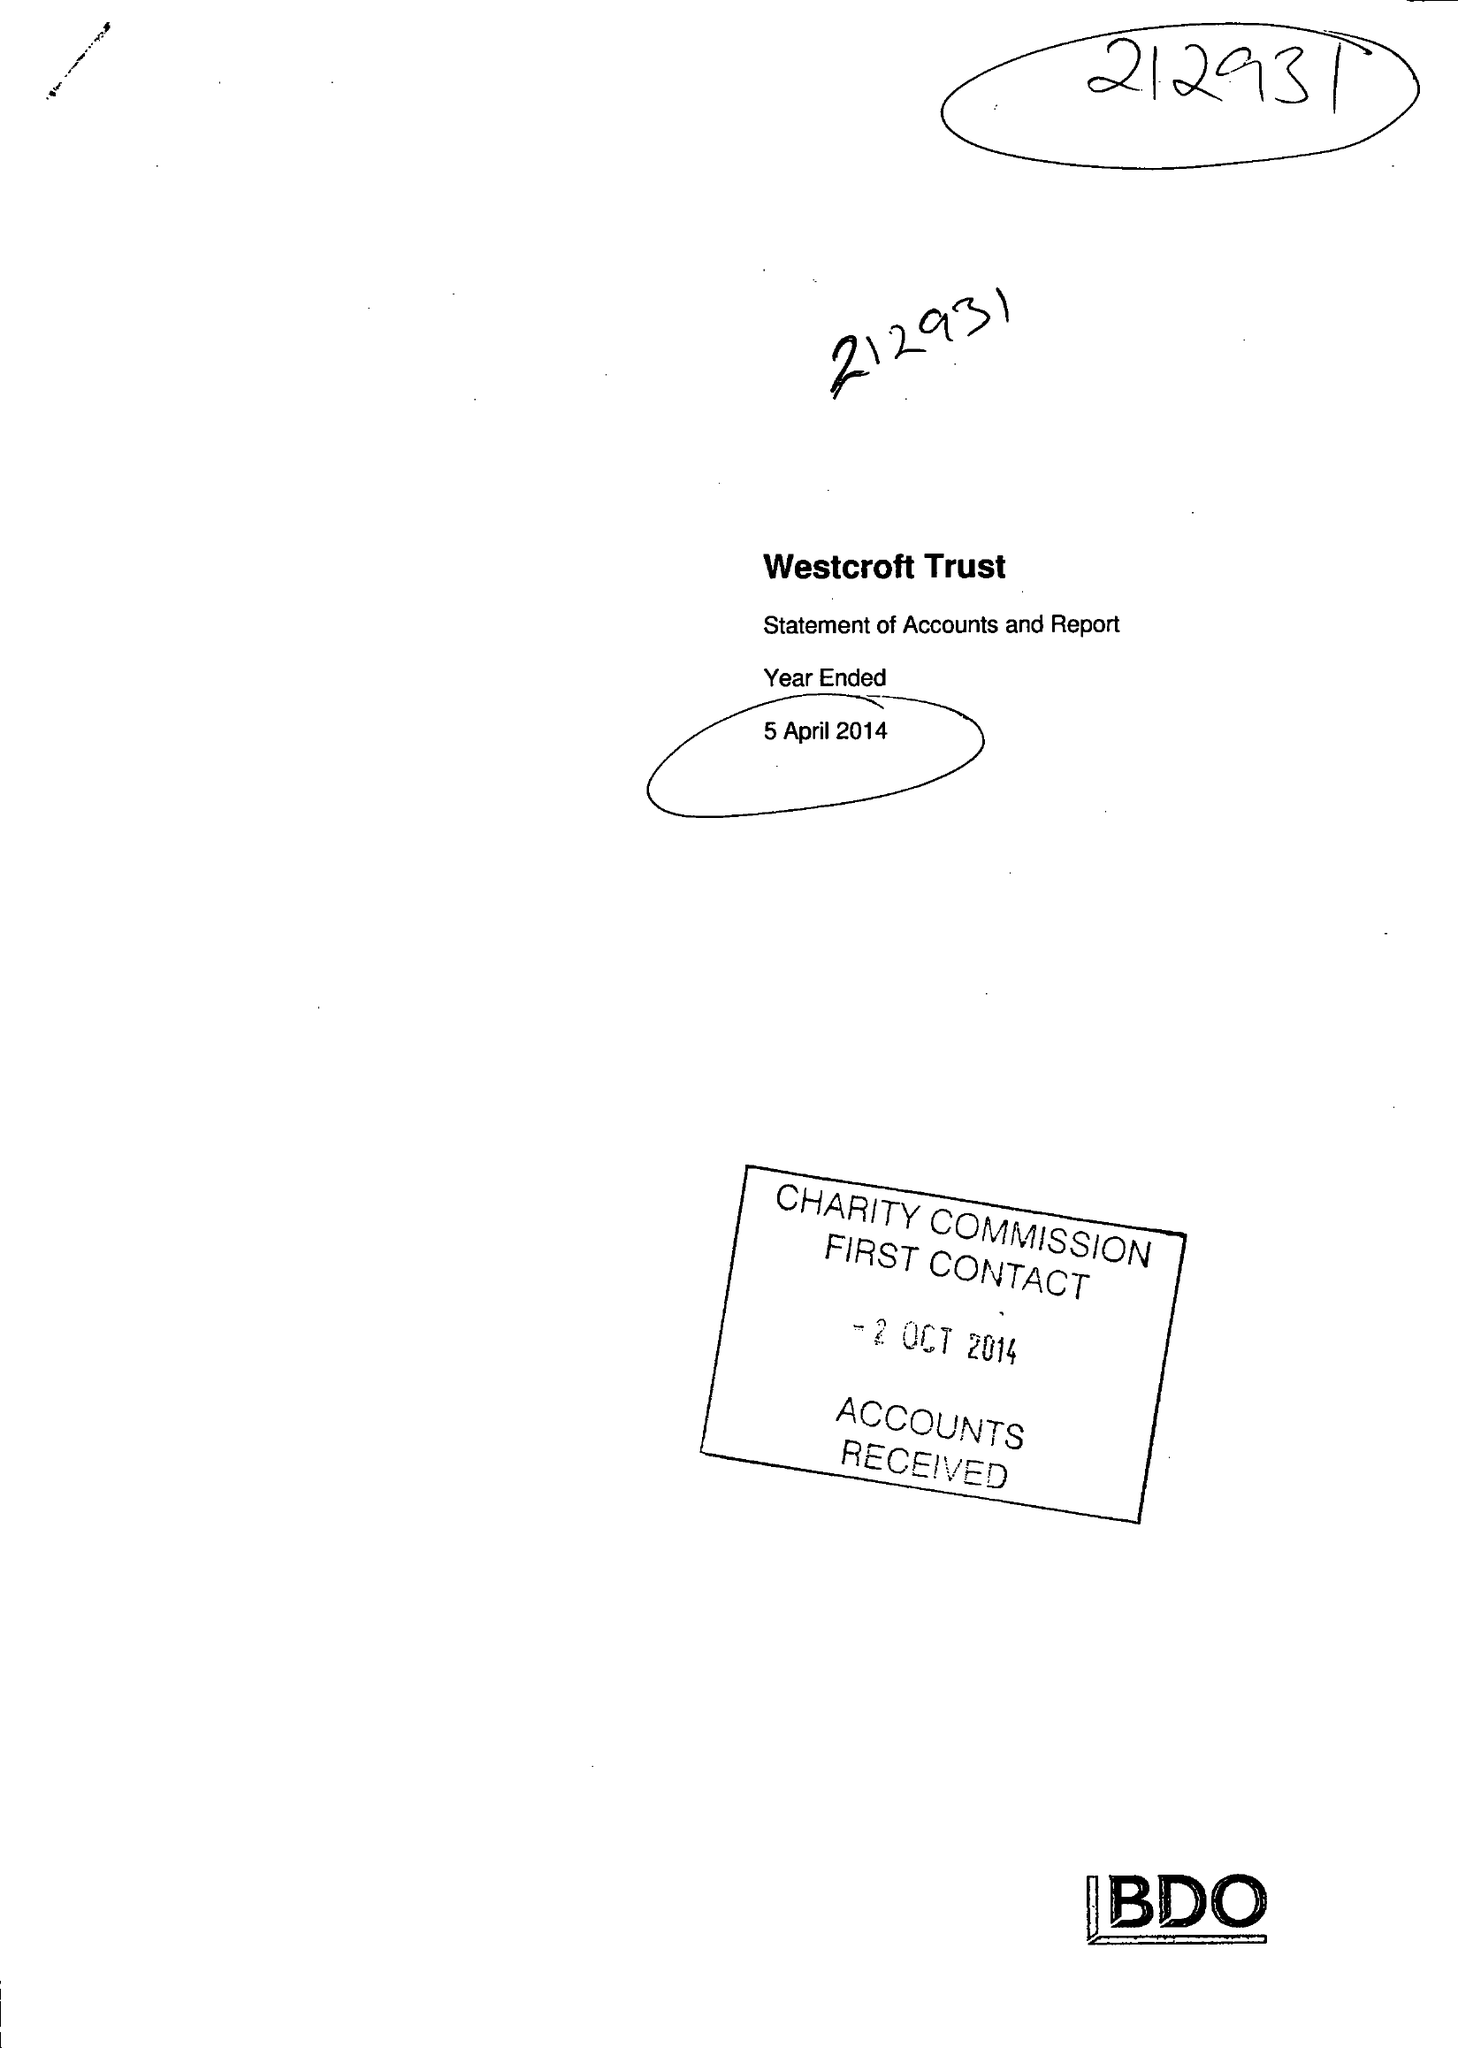What is the value for the address__postcode?
Answer the question using a single word or phrase. SY11 1SJ 